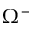Convert formula to latex. <formula><loc_0><loc_0><loc_500><loc_500>\Omega ^ { - }</formula> 